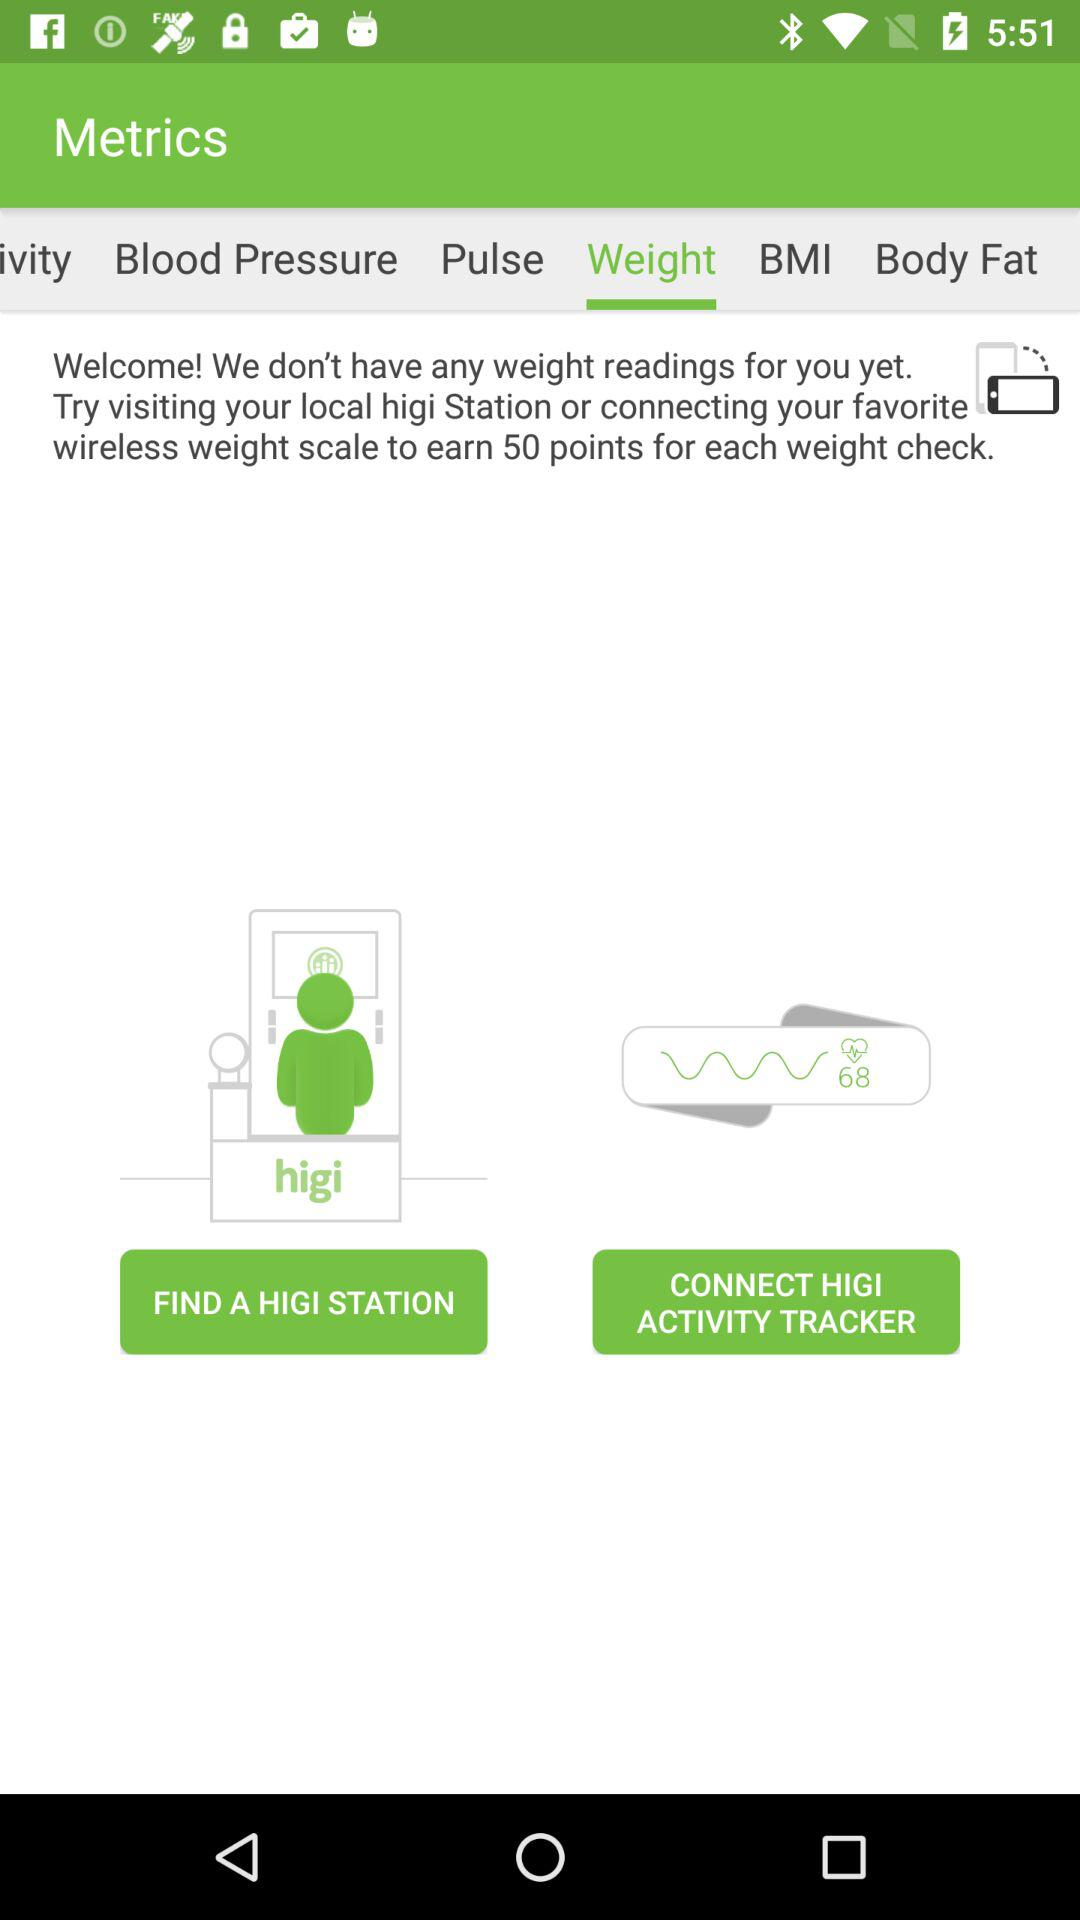How many points can I earn by visiting a HIGI Station and connecting my favorite wireless weight scale?
Answer the question using a single word or phrase. 50 